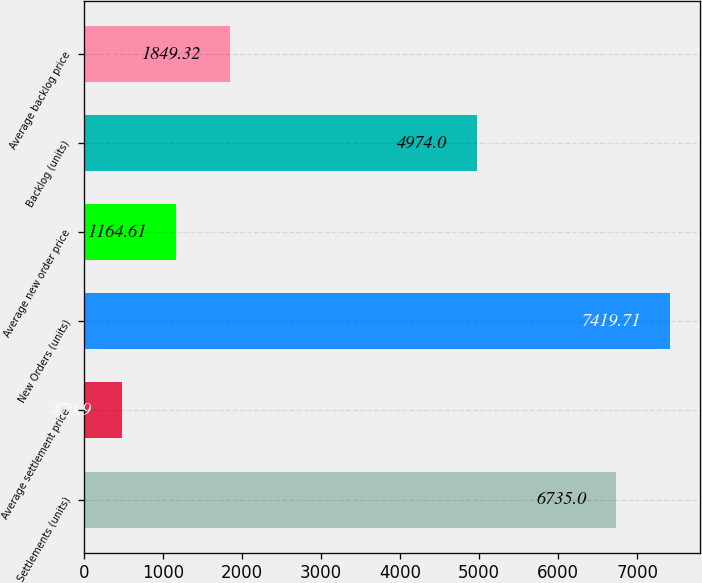Convert chart to OTSL. <chart><loc_0><loc_0><loc_500><loc_500><bar_chart><fcel>Settlements (units)<fcel>Average settlement price<fcel>New Orders (units)<fcel>Average new order price<fcel>Backlog (units)<fcel>Average backlog price<nl><fcel>6735<fcel>479.9<fcel>7419.71<fcel>1164.61<fcel>4974<fcel>1849.32<nl></chart> 